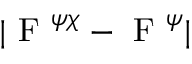<formula> <loc_0><loc_0><loc_500><loc_500>| F ^ { \psi \chi } - F ^ { \psi } |</formula> 